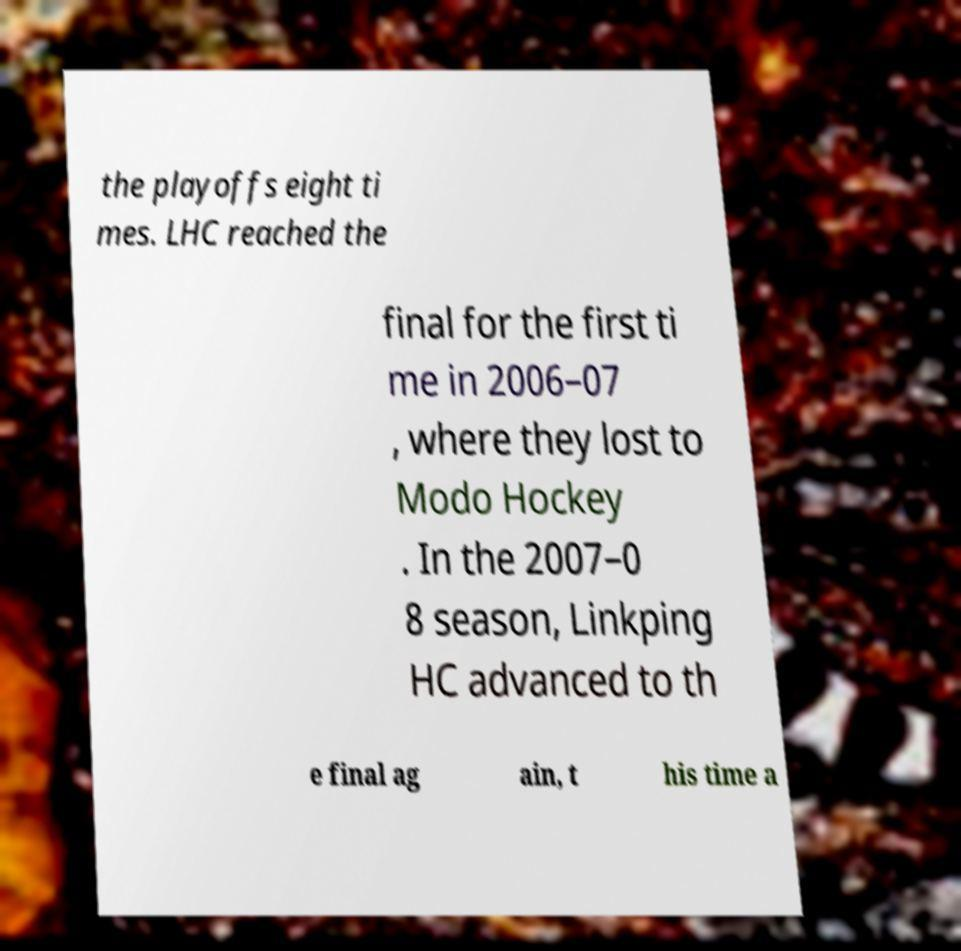Can you read and provide the text displayed in the image?This photo seems to have some interesting text. Can you extract and type it out for me? the playoffs eight ti mes. LHC reached the final for the first ti me in 2006–07 , where they lost to Modo Hockey . In the 2007–0 8 season, Linkping HC advanced to th e final ag ain, t his time a 